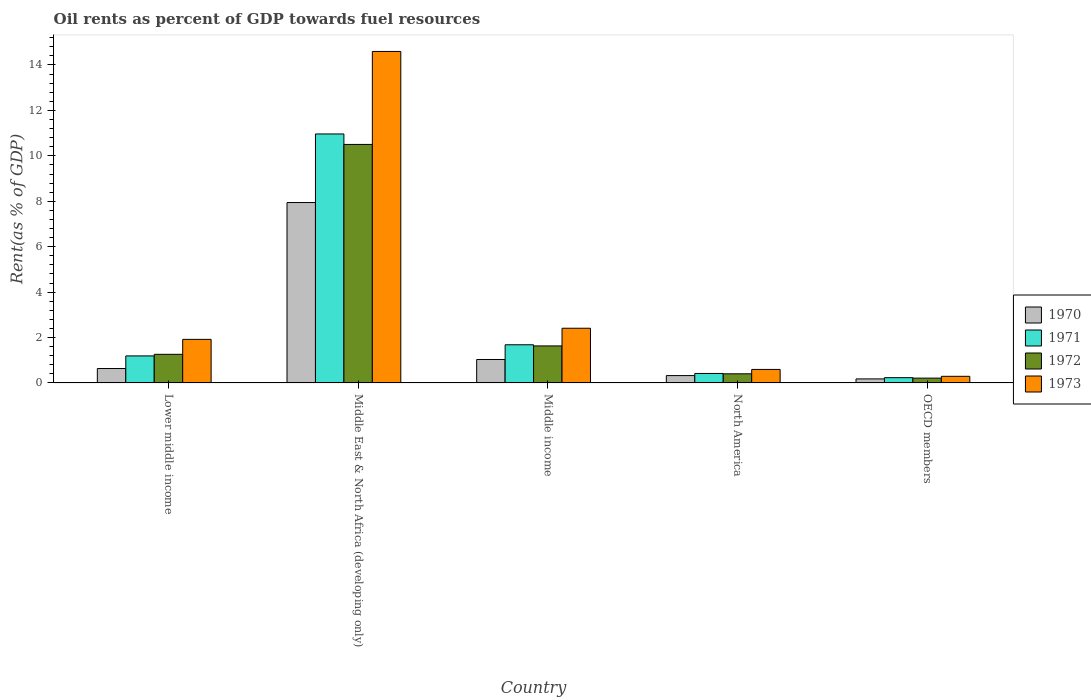How many groups of bars are there?
Offer a terse response. 5. How many bars are there on the 2nd tick from the right?
Offer a terse response. 4. What is the label of the 5th group of bars from the left?
Offer a very short reply. OECD members. In how many cases, is the number of bars for a given country not equal to the number of legend labels?
Your answer should be very brief. 0. What is the oil rent in 1971 in Middle East & North Africa (developing only)?
Your answer should be very brief. 10.96. Across all countries, what is the maximum oil rent in 1970?
Make the answer very short. 7.94. Across all countries, what is the minimum oil rent in 1971?
Give a very brief answer. 0.23. In which country was the oil rent in 1973 maximum?
Keep it short and to the point. Middle East & North Africa (developing only). In which country was the oil rent in 1973 minimum?
Your response must be concise. OECD members. What is the total oil rent in 1972 in the graph?
Your response must be concise. 14.01. What is the difference between the oil rent in 1971 in Middle income and that in North America?
Your answer should be compact. 1.26. What is the difference between the oil rent in 1971 in Lower middle income and the oil rent in 1973 in Middle income?
Offer a very short reply. -1.22. What is the average oil rent in 1971 per country?
Your answer should be very brief. 2.9. What is the difference between the oil rent of/in 1971 and oil rent of/in 1970 in Middle income?
Give a very brief answer. 0.65. What is the ratio of the oil rent in 1973 in Lower middle income to that in North America?
Provide a short and direct response. 3.22. Is the difference between the oil rent in 1971 in Lower middle income and Middle income greater than the difference between the oil rent in 1970 in Lower middle income and Middle income?
Provide a succinct answer. No. What is the difference between the highest and the second highest oil rent in 1973?
Keep it short and to the point. -0.49. What is the difference between the highest and the lowest oil rent in 1972?
Your response must be concise. 10.29. Is the sum of the oil rent in 1971 in Middle East & North Africa (developing only) and North America greater than the maximum oil rent in 1970 across all countries?
Make the answer very short. Yes. What does the 4th bar from the left in Lower middle income represents?
Offer a terse response. 1973. Is it the case that in every country, the sum of the oil rent in 1972 and oil rent in 1970 is greater than the oil rent in 1971?
Provide a short and direct response. Yes. How many bars are there?
Offer a terse response. 20. How many countries are there in the graph?
Ensure brevity in your answer.  5. What is the difference between two consecutive major ticks on the Y-axis?
Provide a short and direct response. 2. Are the values on the major ticks of Y-axis written in scientific E-notation?
Make the answer very short. No. Does the graph contain grids?
Make the answer very short. No. Where does the legend appear in the graph?
Provide a succinct answer. Center right. How many legend labels are there?
Provide a short and direct response. 4. How are the legend labels stacked?
Provide a short and direct response. Vertical. What is the title of the graph?
Ensure brevity in your answer.  Oil rents as percent of GDP towards fuel resources. Does "2013" appear as one of the legend labels in the graph?
Your response must be concise. No. What is the label or title of the X-axis?
Your answer should be compact. Country. What is the label or title of the Y-axis?
Offer a terse response. Rent(as % of GDP). What is the Rent(as % of GDP) of 1970 in Lower middle income?
Offer a terse response. 0.63. What is the Rent(as % of GDP) in 1971 in Lower middle income?
Make the answer very short. 1.19. What is the Rent(as % of GDP) of 1972 in Lower middle income?
Your response must be concise. 1.26. What is the Rent(as % of GDP) in 1973 in Lower middle income?
Give a very brief answer. 1.92. What is the Rent(as % of GDP) in 1970 in Middle East & North Africa (developing only)?
Offer a terse response. 7.94. What is the Rent(as % of GDP) of 1971 in Middle East & North Africa (developing only)?
Offer a terse response. 10.96. What is the Rent(as % of GDP) in 1972 in Middle East & North Africa (developing only)?
Give a very brief answer. 10.5. What is the Rent(as % of GDP) in 1973 in Middle East & North Africa (developing only)?
Offer a terse response. 14.6. What is the Rent(as % of GDP) of 1970 in Middle income?
Your response must be concise. 1.03. What is the Rent(as % of GDP) of 1971 in Middle income?
Make the answer very short. 1.68. What is the Rent(as % of GDP) in 1972 in Middle income?
Give a very brief answer. 1.63. What is the Rent(as % of GDP) of 1973 in Middle income?
Give a very brief answer. 2.41. What is the Rent(as % of GDP) of 1970 in North America?
Your answer should be compact. 0.32. What is the Rent(as % of GDP) in 1971 in North America?
Give a very brief answer. 0.42. What is the Rent(as % of GDP) in 1972 in North America?
Your answer should be very brief. 0.4. What is the Rent(as % of GDP) of 1973 in North America?
Your response must be concise. 0.6. What is the Rent(as % of GDP) of 1970 in OECD members?
Provide a succinct answer. 0.18. What is the Rent(as % of GDP) of 1971 in OECD members?
Ensure brevity in your answer.  0.23. What is the Rent(as % of GDP) of 1972 in OECD members?
Ensure brevity in your answer.  0.21. What is the Rent(as % of GDP) of 1973 in OECD members?
Offer a terse response. 0.29. Across all countries, what is the maximum Rent(as % of GDP) of 1970?
Ensure brevity in your answer.  7.94. Across all countries, what is the maximum Rent(as % of GDP) in 1971?
Provide a succinct answer. 10.96. Across all countries, what is the maximum Rent(as % of GDP) of 1972?
Your response must be concise. 10.5. Across all countries, what is the maximum Rent(as % of GDP) of 1973?
Keep it short and to the point. 14.6. Across all countries, what is the minimum Rent(as % of GDP) of 1970?
Offer a terse response. 0.18. Across all countries, what is the minimum Rent(as % of GDP) in 1971?
Your answer should be very brief. 0.23. Across all countries, what is the minimum Rent(as % of GDP) in 1972?
Your response must be concise. 0.21. Across all countries, what is the minimum Rent(as % of GDP) of 1973?
Your response must be concise. 0.29. What is the total Rent(as % of GDP) of 1970 in the graph?
Offer a terse response. 10.11. What is the total Rent(as % of GDP) in 1971 in the graph?
Give a very brief answer. 14.48. What is the total Rent(as % of GDP) of 1972 in the graph?
Offer a very short reply. 14.01. What is the total Rent(as % of GDP) in 1973 in the graph?
Keep it short and to the point. 19.81. What is the difference between the Rent(as % of GDP) in 1970 in Lower middle income and that in Middle East & North Africa (developing only)?
Offer a terse response. -7.31. What is the difference between the Rent(as % of GDP) of 1971 in Lower middle income and that in Middle East & North Africa (developing only)?
Your answer should be compact. -9.77. What is the difference between the Rent(as % of GDP) of 1972 in Lower middle income and that in Middle East & North Africa (developing only)?
Provide a succinct answer. -9.24. What is the difference between the Rent(as % of GDP) of 1973 in Lower middle income and that in Middle East & North Africa (developing only)?
Make the answer very short. -12.68. What is the difference between the Rent(as % of GDP) of 1970 in Lower middle income and that in Middle income?
Your answer should be very brief. -0.4. What is the difference between the Rent(as % of GDP) in 1971 in Lower middle income and that in Middle income?
Your answer should be compact. -0.49. What is the difference between the Rent(as % of GDP) in 1972 in Lower middle income and that in Middle income?
Your answer should be compact. -0.37. What is the difference between the Rent(as % of GDP) of 1973 in Lower middle income and that in Middle income?
Your answer should be very brief. -0.49. What is the difference between the Rent(as % of GDP) of 1970 in Lower middle income and that in North America?
Your answer should be compact. 0.31. What is the difference between the Rent(as % of GDP) of 1971 in Lower middle income and that in North America?
Your response must be concise. 0.77. What is the difference between the Rent(as % of GDP) of 1972 in Lower middle income and that in North America?
Keep it short and to the point. 0.86. What is the difference between the Rent(as % of GDP) of 1973 in Lower middle income and that in North America?
Offer a terse response. 1.32. What is the difference between the Rent(as % of GDP) in 1970 in Lower middle income and that in OECD members?
Your response must be concise. 0.46. What is the difference between the Rent(as % of GDP) of 1971 in Lower middle income and that in OECD members?
Your response must be concise. 0.96. What is the difference between the Rent(as % of GDP) in 1972 in Lower middle income and that in OECD members?
Provide a short and direct response. 1.05. What is the difference between the Rent(as % of GDP) of 1973 in Lower middle income and that in OECD members?
Ensure brevity in your answer.  1.63. What is the difference between the Rent(as % of GDP) of 1970 in Middle East & North Africa (developing only) and that in Middle income?
Provide a succinct answer. 6.91. What is the difference between the Rent(as % of GDP) of 1971 in Middle East & North Africa (developing only) and that in Middle income?
Keep it short and to the point. 9.28. What is the difference between the Rent(as % of GDP) of 1972 in Middle East & North Africa (developing only) and that in Middle income?
Give a very brief answer. 8.87. What is the difference between the Rent(as % of GDP) of 1973 in Middle East & North Africa (developing only) and that in Middle income?
Your answer should be very brief. 12.19. What is the difference between the Rent(as % of GDP) of 1970 in Middle East & North Africa (developing only) and that in North America?
Your answer should be very brief. 7.62. What is the difference between the Rent(as % of GDP) of 1971 in Middle East & North Africa (developing only) and that in North America?
Your response must be concise. 10.55. What is the difference between the Rent(as % of GDP) in 1972 in Middle East & North Africa (developing only) and that in North America?
Give a very brief answer. 10.1. What is the difference between the Rent(as % of GDP) in 1973 in Middle East & North Africa (developing only) and that in North America?
Ensure brevity in your answer.  14. What is the difference between the Rent(as % of GDP) of 1970 in Middle East & North Africa (developing only) and that in OECD members?
Give a very brief answer. 7.77. What is the difference between the Rent(as % of GDP) of 1971 in Middle East & North Africa (developing only) and that in OECD members?
Ensure brevity in your answer.  10.73. What is the difference between the Rent(as % of GDP) of 1972 in Middle East & North Africa (developing only) and that in OECD members?
Ensure brevity in your answer.  10.29. What is the difference between the Rent(as % of GDP) of 1973 in Middle East & North Africa (developing only) and that in OECD members?
Make the answer very short. 14.3. What is the difference between the Rent(as % of GDP) in 1970 in Middle income and that in North America?
Your response must be concise. 0.71. What is the difference between the Rent(as % of GDP) of 1971 in Middle income and that in North America?
Provide a succinct answer. 1.26. What is the difference between the Rent(as % of GDP) in 1972 in Middle income and that in North America?
Your response must be concise. 1.23. What is the difference between the Rent(as % of GDP) in 1973 in Middle income and that in North America?
Keep it short and to the point. 1.81. What is the difference between the Rent(as % of GDP) in 1970 in Middle income and that in OECD members?
Offer a very short reply. 0.85. What is the difference between the Rent(as % of GDP) in 1971 in Middle income and that in OECD members?
Make the answer very short. 1.45. What is the difference between the Rent(as % of GDP) in 1972 in Middle income and that in OECD members?
Offer a very short reply. 1.42. What is the difference between the Rent(as % of GDP) of 1973 in Middle income and that in OECD members?
Keep it short and to the point. 2.12. What is the difference between the Rent(as % of GDP) in 1970 in North America and that in OECD members?
Your answer should be compact. 0.15. What is the difference between the Rent(as % of GDP) in 1971 in North America and that in OECD members?
Offer a very short reply. 0.18. What is the difference between the Rent(as % of GDP) in 1972 in North America and that in OECD members?
Give a very brief answer. 0.19. What is the difference between the Rent(as % of GDP) of 1973 in North America and that in OECD members?
Ensure brevity in your answer.  0.3. What is the difference between the Rent(as % of GDP) of 1970 in Lower middle income and the Rent(as % of GDP) of 1971 in Middle East & North Africa (developing only)?
Offer a very short reply. -10.33. What is the difference between the Rent(as % of GDP) of 1970 in Lower middle income and the Rent(as % of GDP) of 1972 in Middle East & North Africa (developing only)?
Offer a very short reply. -9.87. What is the difference between the Rent(as % of GDP) in 1970 in Lower middle income and the Rent(as % of GDP) in 1973 in Middle East & North Africa (developing only)?
Offer a very short reply. -13.96. What is the difference between the Rent(as % of GDP) in 1971 in Lower middle income and the Rent(as % of GDP) in 1972 in Middle East & North Africa (developing only)?
Provide a succinct answer. -9.31. What is the difference between the Rent(as % of GDP) in 1971 in Lower middle income and the Rent(as % of GDP) in 1973 in Middle East & North Africa (developing only)?
Make the answer very short. -13.41. What is the difference between the Rent(as % of GDP) of 1972 in Lower middle income and the Rent(as % of GDP) of 1973 in Middle East & North Africa (developing only)?
Your answer should be compact. -13.34. What is the difference between the Rent(as % of GDP) in 1970 in Lower middle income and the Rent(as % of GDP) in 1971 in Middle income?
Your answer should be compact. -1.05. What is the difference between the Rent(as % of GDP) in 1970 in Lower middle income and the Rent(as % of GDP) in 1972 in Middle income?
Your response must be concise. -1. What is the difference between the Rent(as % of GDP) of 1970 in Lower middle income and the Rent(as % of GDP) of 1973 in Middle income?
Offer a terse response. -1.77. What is the difference between the Rent(as % of GDP) of 1971 in Lower middle income and the Rent(as % of GDP) of 1972 in Middle income?
Give a very brief answer. -0.44. What is the difference between the Rent(as % of GDP) in 1971 in Lower middle income and the Rent(as % of GDP) in 1973 in Middle income?
Make the answer very short. -1.22. What is the difference between the Rent(as % of GDP) in 1972 in Lower middle income and the Rent(as % of GDP) in 1973 in Middle income?
Offer a terse response. -1.15. What is the difference between the Rent(as % of GDP) in 1970 in Lower middle income and the Rent(as % of GDP) in 1971 in North America?
Your response must be concise. 0.22. What is the difference between the Rent(as % of GDP) of 1970 in Lower middle income and the Rent(as % of GDP) of 1972 in North America?
Your answer should be very brief. 0.23. What is the difference between the Rent(as % of GDP) of 1970 in Lower middle income and the Rent(as % of GDP) of 1973 in North America?
Your answer should be compact. 0.04. What is the difference between the Rent(as % of GDP) of 1971 in Lower middle income and the Rent(as % of GDP) of 1972 in North America?
Provide a short and direct response. 0.79. What is the difference between the Rent(as % of GDP) of 1971 in Lower middle income and the Rent(as % of GDP) of 1973 in North America?
Offer a very short reply. 0.6. What is the difference between the Rent(as % of GDP) in 1972 in Lower middle income and the Rent(as % of GDP) in 1973 in North America?
Provide a short and direct response. 0.66. What is the difference between the Rent(as % of GDP) of 1970 in Lower middle income and the Rent(as % of GDP) of 1971 in OECD members?
Provide a short and direct response. 0.4. What is the difference between the Rent(as % of GDP) in 1970 in Lower middle income and the Rent(as % of GDP) in 1972 in OECD members?
Keep it short and to the point. 0.42. What is the difference between the Rent(as % of GDP) of 1970 in Lower middle income and the Rent(as % of GDP) of 1973 in OECD members?
Provide a short and direct response. 0.34. What is the difference between the Rent(as % of GDP) in 1971 in Lower middle income and the Rent(as % of GDP) in 1972 in OECD members?
Your answer should be compact. 0.98. What is the difference between the Rent(as % of GDP) of 1971 in Lower middle income and the Rent(as % of GDP) of 1973 in OECD members?
Your answer should be compact. 0.9. What is the difference between the Rent(as % of GDP) of 1972 in Lower middle income and the Rent(as % of GDP) of 1973 in OECD members?
Provide a succinct answer. 0.97. What is the difference between the Rent(as % of GDP) of 1970 in Middle East & North Africa (developing only) and the Rent(as % of GDP) of 1971 in Middle income?
Ensure brevity in your answer.  6.26. What is the difference between the Rent(as % of GDP) of 1970 in Middle East & North Africa (developing only) and the Rent(as % of GDP) of 1972 in Middle income?
Offer a very short reply. 6.31. What is the difference between the Rent(as % of GDP) in 1970 in Middle East & North Africa (developing only) and the Rent(as % of GDP) in 1973 in Middle income?
Keep it short and to the point. 5.53. What is the difference between the Rent(as % of GDP) in 1971 in Middle East & North Africa (developing only) and the Rent(as % of GDP) in 1972 in Middle income?
Ensure brevity in your answer.  9.33. What is the difference between the Rent(as % of GDP) of 1971 in Middle East & North Africa (developing only) and the Rent(as % of GDP) of 1973 in Middle income?
Ensure brevity in your answer.  8.55. What is the difference between the Rent(as % of GDP) in 1972 in Middle East & North Africa (developing only) and the Rent(as % of GDP) in 1973 in Middle income?
Give a very brief answer. 8.09. What is the difference between the Rent(as % of GDP) of 1970 in Middle East & North Africa (developing only) and the Rent(as % of GDP) of 1971 in North America?
Provide a short and direct response. 7.53. What is the difference between the Rent(as % of GDP) in 1970 in Middle East & North Africa (developing only) and the Rent(as % of GDP) in 1972 in North America?
Provide a succinct answer. 7.54. What is the difference between the Rent(as % of GDP) in 1970 in Middle East & North Africa (developing only) and the Rent(as % of GDP) in 1973 in North America?
Your answer should be compact. 7.35. What is the difference between the Rent(as % of GDP) in 1971 in Middle East & North Africa (developing only) and the Rent(as % of GDP) in 1972 in North America?
Provide a succinct answer. 10.56. What is the difference between the Rent(as % of GDP) of 1971 in Middle East & North Africa (developing only) and the Rent(as % of GDP) of 1973 in North America?
Offer a terse response. 10.37. What is the difference between the Rent(as % of GDP) of 1972 in Middle East & North Africa (developing only) and the Rent(as % of GDP) of 1973 in North America?
Your answer should be very brief. 9.91. What is the difference between the Rent(as % of GDP) of 1970 in Middle East & North Africa (developing only) and the Rent(as % of GDP) of 1971 in OECD members?
Your answer should be very brief. 7.71. What is the difference between the Rent(as % of GDP) in 1970 in Middle East & North Africa (developing only) and the Rent(as % of GDP) in 1972 in OECD members?
Your answer should be compact. 7.73. What is the difference between the Rent(as % of GDP) in 1970 in Middle East & North Africa (developing only) and the Rent(as % of GDP) in 1973 in OECD members?
Provide a short and direct response. 7.65. What is the difference between the Rent(as % of GDP) of 1971 in Middle East & North Africa (developing only) and the Rent(as % of GDP) of 1972 in OECD members?
Offer a terse response. 10.75. What is the difference between the Rent(as % of GDP) of 1971 in Middle East & North Africa (developing only) and the Rent(as % of GDP) of 1973 in OECD members?
Your response must be concise. 10.67. What is the difference between the Rent(as % of GDP) in 1972 in Middle East & North Africa (developing only) and the Rent(as % of GDP) in 1973 in OECD members?
Offer a terse response. 10.21. What is the difference between the Rent(as % of GDP) of 1970 in Middle income and the Rent(as % of GDP) of 1971 in North America?
Your answer should be compact. 0.61. What is the difference between the Rent(as % of GDP) of 1970 in Middle income and the Rent(as % of GDP) of 1972 in North America?
Ensure brevity in your answer.  0.63. What is the difference between the Rent(as % of GDP) of 1970 in Middle income and the Rent(as % of GDP) of 1973 in North America?
Provide a short and direct response. 0.44. What is the difference between the Rent(as % of GDP) of 1971 in Middle income and the Rent(as % of GDP) of 1972 in North America?
Offer a terse response. 1.28. What is the difference between the Rent(as % of GDP) of 1971 in Middle income and the Rent(as % of GDP) of 1973 in North America?
Provide a succinct answer. 1.09. What is the difference between the Rent(as % of GDP) in 1972 in Middle income and the Rent(as % of GDP) in 1973 in North America?
Provide a short and direct response. 1.04. What is the difference between the Rent(as % of GDP) of 1970 in Middle income and the Rent(as % of GDP) of 1971 in OECD members?
Keep it short and to the point. 0.8. What is the difference between the Rent(as % of GDP) of 1970 in Middle income and the Rent(as % of GDP) of 1972 in OECD members?
Your answer should be compact. 0.82. What is the difference between the Rent(as % of GDP) of 1970 in Middle income and the Rent(as % of GDP) of 1973 in OECD members?
Provide a succinct answer. 0.74. What is the difference between the Rent(as % of GDP) in 1971 in Middle income and the Rent(as % of GDP) in 1972 in OECD members?
Provide a short and direct response. 1.47. What is the difference between the Rent(as % of GDP) in 1971 in Middle income and the Rent(as % of GDP) in 1973 in OECD members?
Offer a terse response. 1.39. What is the difference between the Rent(as % of GDP) in 1972 in Middle income and the Rent(as % of GDP) in 1973 in OECD members?
Ensure brevity in your answer.  1.34. What is the difference between the Rent(as % of GDP) in 1970 in North America and the Rent(as % of GDP) in 1971 in OECD members?
Give a very brief answer. 0.09. What is the difference between the Rent(as % of GDP) of 1970 in North America and the Rent(as % of GDP) of 1972 in OECD members?
Your answer should be compact. 0.11. What is the difference between the Rent(as % of GDP) in 1970 in North America and the Rent(as % of GDP) in 1973 in OECD members?
Your answer should be compact. 0.03. What is the difference between the Rent(as % of GDP) in 1971 in North America and the Rent(as % of GDP) in 1972 in OECD members?
Your answer should be very brief. 0.21. What is the difference between the Rent(as % of GDP) in 1971 in North America and the Rent(as % of GDP) in 1973 in OECD members?
Ensure brevity in your answer.  0.13. What is the difference between the Rent(as % of GDP) of 1972 in North America and the Rent(as % of GDP) of 1973 in OECD members?
Give a very brief answer. 0.11. What is the average Rent(as % of GDP) in 1970 per country?
Provide a succinct answer. 2.02. What is the average Rent(as % of GDP) of 1971 per country?
Offer a terse response. 2.9. What is the average Rent(as % of GDP) of 1972 per country?
Give a very brief answer. 2.8. What is the average Rent(as % of GDP) in 1973 per country?
Give a very brief answer. 3.96. What is the difference between the Rent(as % of GDP) in 1970 and Rent(as % of GDP) in 1971 in Lower middle income?
Your answer should be very brief. -0.56. What is the difference between the Rent(as % of GDP) of 1970 and Rent(as % of GDP) of 1972 in Lower middle income?
Ensure brevity in your answer.  -0.62. What is the difference between the Rent(as % of GDP) in 1970 and Rent(as % of GDP) in 1973 in Lower middle income?
Offer a very short reply. -1.28. What is the difference between the Rent(as % of GDP) of 1971 and Rent(as % of GDP) of 1972 in Lower middle income?
Your response must be concise. -0.07. What is the difference between the Rent(as % of GDP) in 1971 and Rent(as % of GDP) in 1973 in Lower middle income?
Your answer should be very brief. -0.73. What is the difference between the Rent(as % of GDP) of 1972 and Rent(as % of GDP) of 1973 in Lower middle income?
Provide a succinct answer. -0.66. What is the difference between the Rent(as % of GDP) in 1970 and Rent(as % of GDP) in 1971 in Middle East & North Africa (developing only)?
Keep it short and to the point. -3.02. What is the difference between the Rent(as % of GDP) in 1970 and Rent(as % of GDP) in 1972 in Middle East & North Africa (developing only)?
Provide a short and direct response. -2.56. What is the difference between the Rent(as % of GDP) in 1970 and Rent(as % of GDP) in 1973 in Middle East & North Africa (developing only)?
Give a very brief answer. -6.65. What is the difference between the Rent(as % of GDP) of 1971 and Rent(as % of GDP) of 1972 in Middle East & North Africa (developing only)?
Offer a terse response. 0.46. What is the difference between the Rent(as % of GDP) in 1971 and Rent(as % of GDP) in 1973 in Middle East & North Africa (developing only)?
Your answer should be compact. -3.63. What is the difference between the Rent(as % of GDP) of 1972 and Rent(as % of GDP) of 1973 in Middle East & North Africa (developing only)?
Ensure brevity in your answer.  -4.09. What is the difference between the Rent(as % of GDP) in 1970 and Rent(as % of GDP) in 1971 in Middle income?
Provide a succinct answer. -0.65. What is the difference between the Rent(as % of GDP) in 1970 and Rent(as % of GDP) in 1972 in Middle income?
Your answer should be very brief. -0.6. What is the difference between the Rent(as % of GDP) in 1970 and Rent(as % of GDP) in 1973 in Middle income?
Your answer should be compact. -1.38. What is the difference between the Rent(as % of GDP) in 1971 and Rent(as % of GDP) in 1972 in Middle income?
Offer a very short reply. 0.05. What is the difference between the Rent(as % of GDP) of 1971 and Rent(as % of GDP) of 1973 in Middle income?
Offer a terse response. -0.73. What is the difference between the Rent(as % of GDP) in 1972 and Rent(as % of GDP) in 1973 in Middle income?
Make the answer very short. -0.78. What is the difference between the Rent(as % of GDP) of 1970 and Rent(as % of GDP) of 1971 in North America?
Make the answer very short. -0.09. What is the difference between the Rent(as % of GDP) of 1970 and Rent(as % of GDP) of 1972 in North America?
Ensure brevity in your answer.  -0.08. What is the difference between the Rent(as % of GDP) of 1970 and Rent(as % of GDP) of 1973 in North America?
Your response must be concise. -0.27. What is the difference between the Rent(as % of GDP) in 1971 and Rent(as % of GDP) in 1972 in North America?
Your answer should be very brief. 0.02. What is the difference between the Rent(as % of GDP) in 1971 and Rent(as % of GDP) in 1973 in North America?
Keep it short and to the point. -0.18. What is the difference between the Rent(as % of GDP) of 1972 and Rent(as % of GDP) of 1973 in North America?
Your answer should be compact. -0.19. What is the difference between the Rent(as % of GDP) in 1970 and Rent(as % of GDP) in 1971 in OECD members?
Offer a very short reply. -0.05. What is the difference between the Rent(as % of GDP) of 1970 and Rent(as % of GDP) of 1972 in OECD members?
Your answer should be very brief. -0.03. What is the difference between the Rent(as % of GDP) of 1970 and Rent(as % of GDP) of 1973 in OECD members?
Your response must be concise. -0.11. What is the difference between the Rent(as % of GDP) of 1971 and Rent(as % of GDP) of 1972 in OECD members?
Ensure brevity in your answer.  0.02. What is the difference between the Rent(as % of GDP) of 1971 and Rent(as % of GDP) of 1973 in OECD members?
Offer a terse response. -0.06. What is the difference between the Rent(as % of GDP) in 1972 and Rent(as % of GDP) in 1973 in OECD members?
Your answer should be very brief. -0.08. What is the ratio of the Rent(as % of GDP) in 1970 in Lower middle income to that in Middle East & North Africa (developing only)?
Offer a terse response. 0.08. What is the ratio of the Rent(as % of GDP) of 1971 in Lower middle income to that in Middle East & North Africa (developing only)?
Ensure brevity in your answer.  0.11. What is the ratio of the Rent(as % of GDP) of 1972 in Lower middle income to that in Middle East & North Africa (developing only)?
Offer a very short reply. 0.12. What is the ratio of the Rent(as % of GDP) in 1973 in Lower middle income to that in Middle East & North Africa (developing only)?
Make the answer very short. 0.13. What is the ratio of the Rent(as % of GDP) of 1970 in Lower middle income to that in Middle income?
Offer a very short reply. 0.61. What is the ratio of the Rent(as % of GDP) in 1971 in Lower middle income to that in Middle income?
Offer a very short reply. 0.71. What is the ratio of the Rent(as % of GDP) of 1972 in Lower middle income to that in Middle income?
Your answer should be very brief. 0.77. What is the ratio of the Rent(as % of GDP) in 1973 in Lower middle income to that in Middle income?
Ensure brevity in your answer.  0.8. What is the ratio of the Rent(as % of GDP) of 1970 in Lower middle income to that in North America?
Offer a very short reply. 1.96. What is the ratio of the Rent(as % of GDP) in 1971 in Lower middle income to that in North America?
Your response must be concise. 2.85. What is the ratio of the Rent(as % of GDP) in 1972 in Lower middle income to that in North America?
Provide a succinct answer. 3.13. What is the ratio of the Rent(as % of GDP) in 1973 in Lower middle income to that in North America?
Provide a succinct answer. 3.22. What is the ratio of the Rent(as % of GDP) of 1970 in Lower middle income to that in OECD members?
Offer a terse response. 3.57. What is the ratio of the Rent(as % of GDP) of 1971 in Lower middle income to that in OECD members?
Your answer should be very brief. 5.12. What is the ratio of the Rent(as % of GDP) in 1972 in Lower middle income to that in OECD members?
Ensure brevity in your answer.  5.94. What is the ratio of the Rent(as % of GDP) in 1973 in Lower middle income to that in OECD members?
Offer a very short reply. 6.58. What is the ratio of the Rent(as % of GDP) in 1970 in Middle East & North Africa (developing only) to that in Middle income?
Keep it short and to the point. 7.69. What is the ratio of the Rent(as % of GDP) in 1971 in Middle East & North Africa (developing only) to that in Middle income?
Keep it short and to the point. 6.52. What is the ratio of the Rent(as % of GDP) of 1972 in Middle East & North Africa (developing only) to that in Middle income?
Make the answer very short. 6.44. What is the ratio of the Rent(as % of GDP) of 1973 in Middle East & North Africa (developing only) to that in Middle income?
Your answer should be very brief. 6.06. What is the ratio of the Rent(as % of GDP) of 1970 in Middle East & North Africa (developing only) to that in North America?
Offer a terse response. 24.54. What is the ratio of the Rent(as % of GDP) in 1971 in Middle East & North Africa (developing only) to that in North America?
Your answer should be very brief. 26.26. What is the ratio of the Rent(as % of GDP) in 1972 in Middle East & North Africa (developing only) to that in North America?
Your response must be concise. 26.11. What is the ratio of the Rent(as % of GDP) of 1973 in Middle East & North Africa (developing only) to that in North America?
Your answer should be very brief. 24.53. What is the ratio of the Rent(as % of GDP) in 1970 in Middle East & North Africa (developing only) to that in OECD members?
Your answer should be very brief. 44.68. What is the ratio of the Rent(as % of GDP) of 1971 in Middle East & North Africa (developing only) to that in OECD members?
Keep it short and to the point. 47.15. What is the ratio of the Rent(as % of GDP) of 1972 in Middle East & North Africa (developing only) to that in OECD members?
Your response must be concise. 49.49. What is the ratio of the Rent(as % of GDP) of 1973 in Middle East & North Africa (developing only) to that in OECD members?
Your answer should be compact. 50.04. What is the ratio of the Rent(as % of GDP) of 1970 in Middle income to that in North America?
Your answer should be compact. 3.19. What is the ratio of the Rent(as % of GDP) of 1971 in Middle income to that in North America?
Make the answer very short. 4.03. What is the ratio of the Rent(as % of GDP) in 1972 in Middle income to that in North America?
Give a very brief answer. 4.05. What is the ratio of the Rent(as % of GDP) of 1973 in Middle income to that in North America?
Offer a terse response. 4.05. What is the ratio of the Rent(as % of GDP) in 1970 in Middle income to that in OECD members?
Give a very brief answer. 5.81. What is the ratio of the Rent(as % of GDP) of 1971 in Middle income to that in OECD members?
Give a very brief answer. 7.23. What is the ratio of the Rent(as % of GDP) in 1972 in Middle income to that in OECD members?
Your answer should be compact. 7.68. What is the ratio of the Rent(as % of GDP) in 1973 in Middle income to that in OECD members?
Your response must be concise. 8.26. What is the ratio of the Rent(as % of GDP) of 1970 in North America to that in OECD members?
Provide a succinct answer. 1.82. What is the ratio of the Rent(as % of GDP) in 1971 in North America to that in OECD members?
Offer a very short reply. 1.8. What is the ratio of the Rent(as % of GDP) of 1972 in North America to that in OECD members?
Your answer should be compact. 1.9. What is the ratio of the Rent(as % of GDP) of 1973 in North America to that in OECD members?
Offer a very short reply. 2.04. What is the difference between the highest and the second highest Rent(as % of GDP) of 1970?
Provide a short and direct response. 6.91. What is the difference between the highest and the second highest Rent(as % of GDP) of 1971?
Provide a succinct answer. 9.28. What is the difference between the highest and the second highest Rent(as % of GDP) of 1972?
Provide a short and direct response. 8.87. What is the difference between the highest and the second highest Rent(as % of GDP) in 1973?
Your response must be concise. 12.19. What is the difference between the highest and the lowest Rent(as % of GDP) of 1970?
Offer a terse response. 7.77. What is the difference between the highest and the lowest Rent(as % of GDP) in 1971?
Keep it short and to the point. 10.73. What is the difference between the highest and the lowest Rent(as % of GDP) of 1972?
Offer a very short reply. 10.29. What is the difference between the highest and the lowest Rent(as % of GDP) in 1973?
Provide a short and direct response. 14.3. 